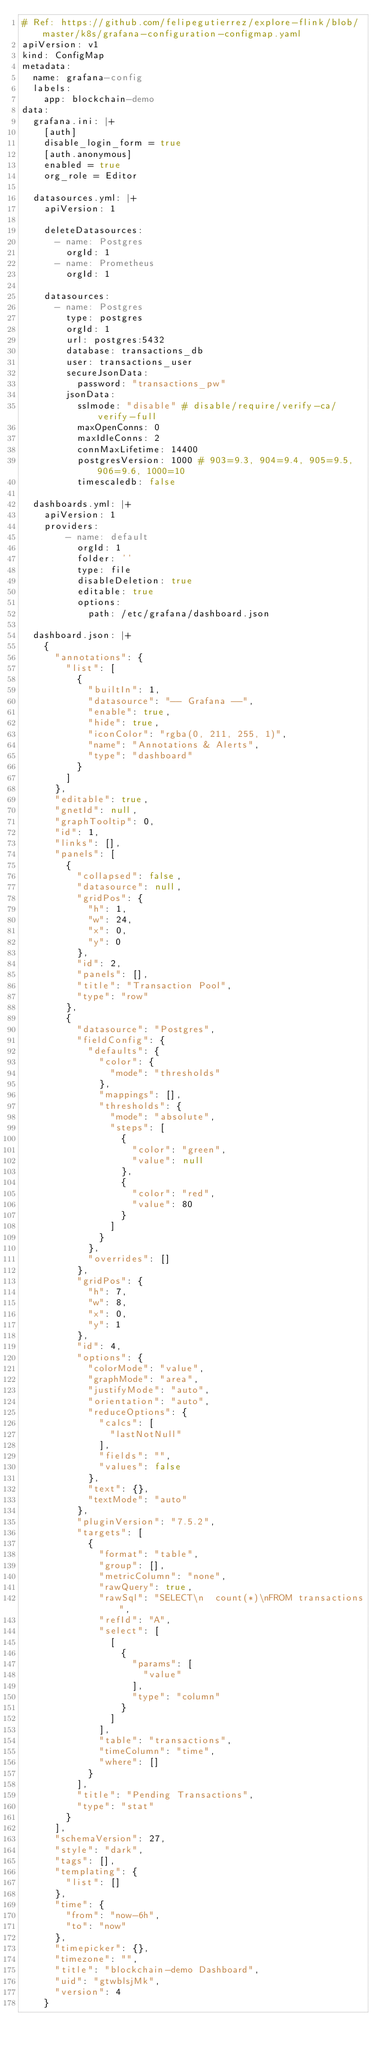<code> <loc_0><loc_0><loc_500><loc_500><_YAML_># Ref: https://github.com/felipegutierrez/explore-flink/blob/master/k8s/grafana-configuration-configmap.yaml
apiVersion: v1
kind: ConfigMap
metadata:
  name: grafana-config
  labels:
    app: blockchain-demo
data:
  grafana.ini: |+
    [auth]
    disable_login_form = true
    [auth.anonymous]
    enabled = true
    org_role = Editor

  datasources.yml: |+
    apiVersion: 1

    deleteDatasources:
      - name: Postgres
        orgId: 1
      - name: Prometheus
        orgId: 1
    
    datasources:
      - name: Postgres
        type: postgres
        orgId: 1
        url: postgres:5432
        database: transactions_db
        user: transactions_user
        secureJsonData:
          password: "transactions_pw"
        jsonData:
          sslmode: "disable" # disable/require/verify-ca/verify-full
          maxOpenConns: 0         
          maxIdleConns: 2
          connMaxLifetime: 14400
          postgresVersion: 1000 # 903=9.3, 904=9.4, 905=9.5, 906=9.6, 1000=10
          timescaledb: false

  dashboards.yml: |+
    apiVersion: 1
    providers:
        - name: default
          orgId: 1
          folder: ''
          type: file
          disableDeletion: true
          editable: true
          options:
            path: /etc/grafana/dashboard.json

  dashboard.json: |+
    {
      "annotations": {
        "list": [
          {
            "builtIn": 1,
            "datasource": "-- Grafana --",
            "enable": true,
            "hide": true,
            "iconColor": "rgba(0, 211, 255, 1)",
            "name": "Annotations & Alerts",
            "type": "dashboard"
          }
        ]
      },
      "editable": true,
      "gnetId": null,
      "graphTooltip": 0,
      "id": 1,
      "links": [],
      "panels": [
        {
          "collapsed": false,
          "datasource": null,
          "gridPos": {
            "h": 1,
            "w": 24,
            "x": 0,
            "y": 0
          },
          "id": 2,
          "panels": [],
          "title": "Transaction Pool",
          "type": "row"
        },
        {
          "datasource": "Postgres",
          "fieldConfig": {
            "defaults": {
              "color": {
                "mode": "thresholds"
              },
              "mappings": [],
              "thresholds": {
                "mode": "absolute",
                "steps": [
                  {
                    "color": "green",
                    "value": null
                  },
                  {
                    "color": "red",
                    "value": 80
                  }
                ]
              }
            },
            "overrides": []
          },
          "gridPos": {
            "h": 7,
            "w": 8,
            "x": 0,
            "y": 1
          },
          "id": 4,
          "options": {
            "colorMode": "value",
            "graphMode": "area",
            "justifyMode": "auto",
            "orientation": "auto",
            "reduceOptions": {
              "calcs": [
                "lastNotNull"
              ],
              "fields": "",
              "values": false
            },
            "text": {},
            "textMode": "auto"
          },
          "pluginVersion": "7.5.2",
          "targets": [
            {
              "format": "table",
              "group": [],
              "metricColumn": "none",
              "rawQuery": true,
              "rawSql": "SELECT\n  count(*)\nFROM transactions",
              "refId": "A",
              "select": [
                [
                  {
                    "params": [
                      "value"
                    ],
                    "type": "column"
                  }
                ]
              ],
              "table": "transactions",
              "timeColumn": "time",
              "where": []
            }
          ],
          "title": "Pending Transactions",
          "type": "stat"
        }
      ],
      "schemaVersion": 27,
      "style": "dark",
      "tags": [],
      "templating": {
        "list": []
      },
      "time": {
        "from": "now-6h",
        "to": "now"
      },
      "timepicker": {},
      "timezone": "",
      "title": "blockchain-demo Dashboard",
      "uid": "gtwblsjMk",
      "version": 4
    }</code> 